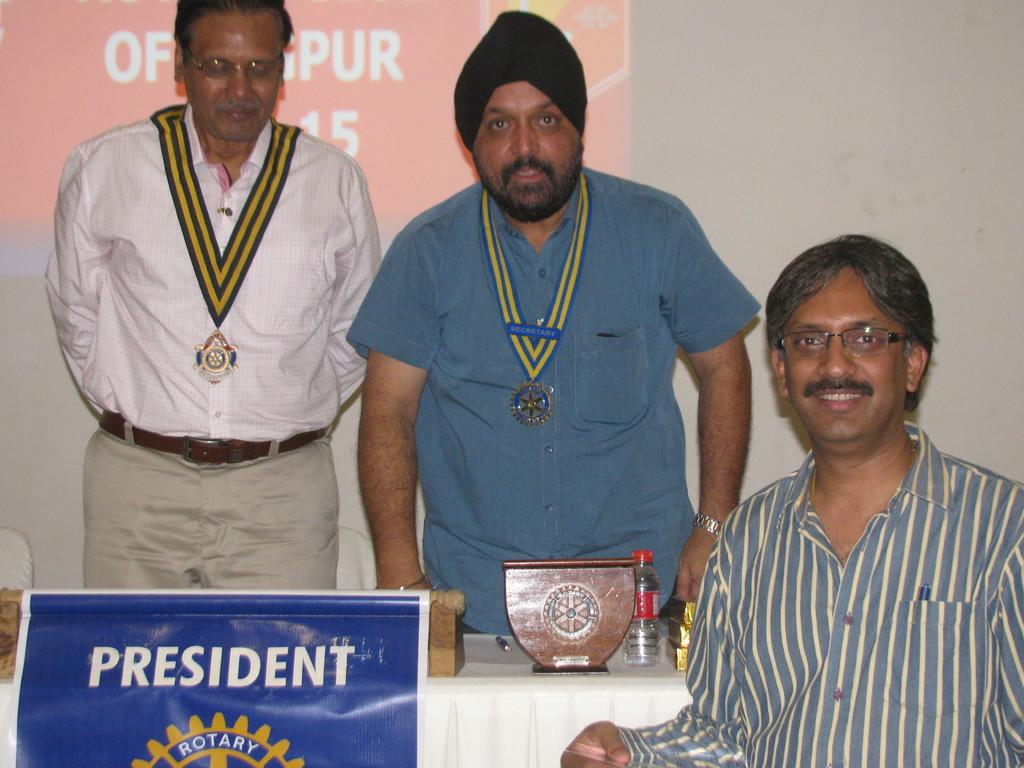<image>
Create a compact narrative representing the image presented. Three men sit behind a sing with the word rotary on it. 